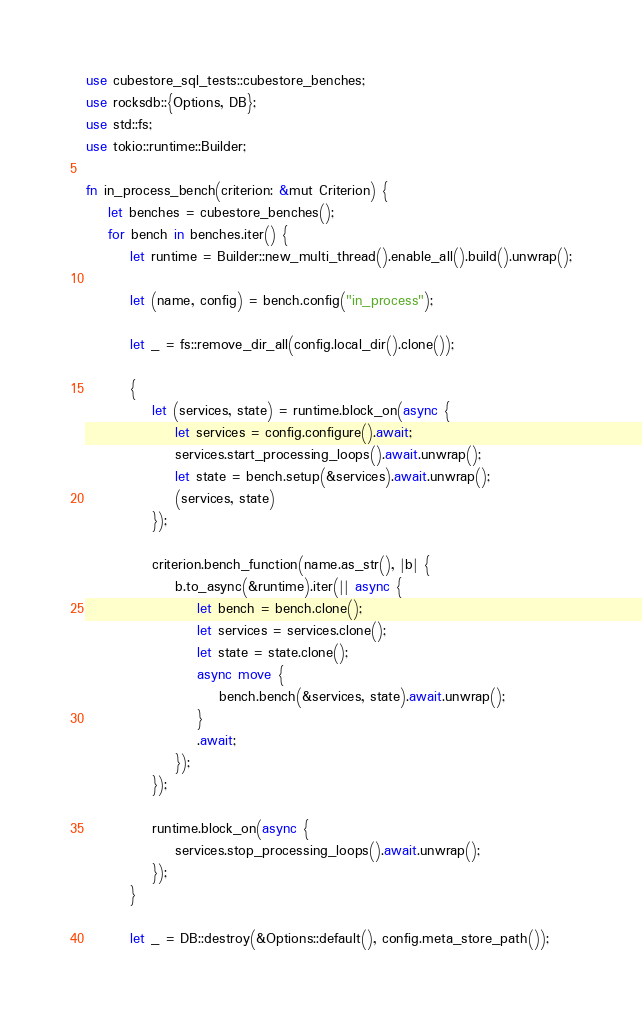Convert code to text. <code><loc_0><loc_0><loc_500><loc_500><_Rust_>use cubestore_sql_tests::cubestore_benches;
use rocksdb::{Options, DB};
use std::fs;
use tokio::runtime::Builder;

fn in_process_bench(criterion: &mut Criterion) {
    let benches = cubestore_benches();
    for bench in benches.iter() {
        let runtime = Builder::new_multi_thread().enable_all().build().unwrap();

        let (name, config) = bench.config("in_process");

        let _ = fs::remove_dir_all(config.local_dir().clone());

        {
            let (services, state) = runtime.block_on(async {
                let services = config.configure().await;
                services.start_processing_loops().await.unwrap();
                let state = bench.setup(&services).await.unwrap();
                (services, state)
            });

            criterion.bench_function(name.as_str(), |b| {
                b.to_async(&runtime).iter(|| async {
                    let bench = bench.clone();
                    let services = services.clone();
                    let state = state.clone();
                    async move {
                        bench.bench(&services, state).await.unwrap();
                    }
                    .await;
                });
            });

            runtime.block_on(async {
                services.stop_processing_loops().await.unwrap();
            });
        }

        let _ = DB::destroy(&Options::default(), config.meta_store_path());</code> 